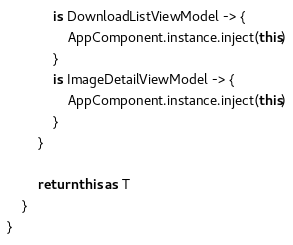Convert code to text. <code><loc_0><loc_0><loc_500><loc_500><_Kotlin_>            is DownloadListViewModel -> {
                AppComponent.instance.inject(this)
            }
            is ImageDetailViewModel -> {
                AppComponent.instance.inject(this)
            }
        }

        return this as T
    }
}</code> 